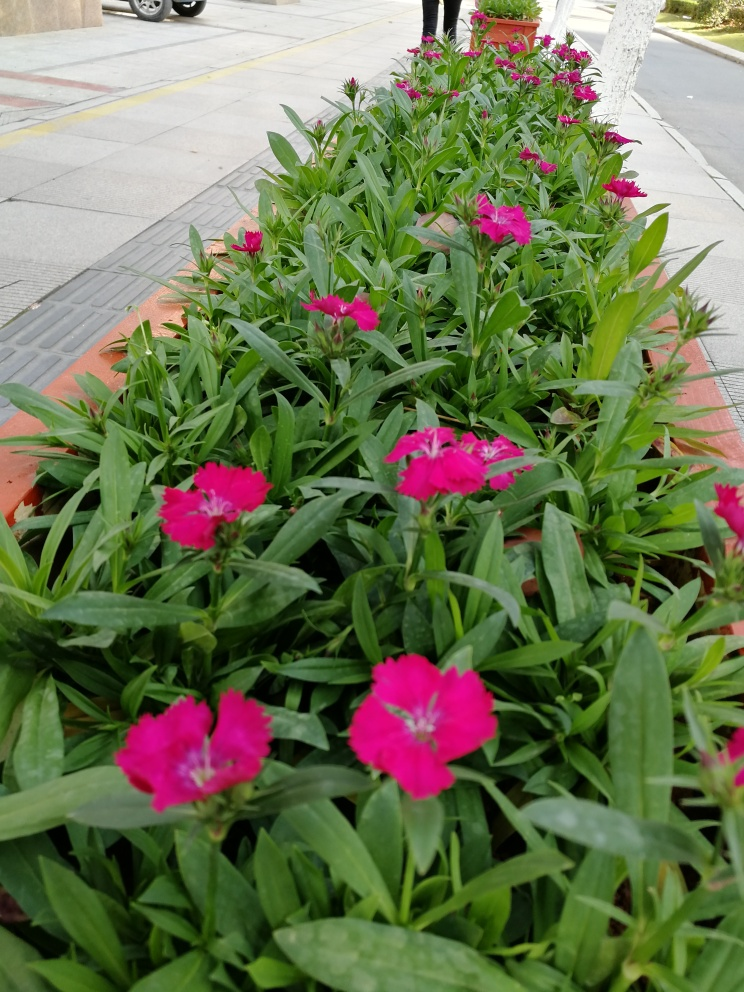How are the colors in this image? The colors in the image are fairly vibrant, with the rich pink of the flowers creating a striking contrast against the lush green of the leaves. The visual appeal is heightened by the natural distribution of the blossoms among the foliage, making the color palette more engaging than a monotonous or dull display. 